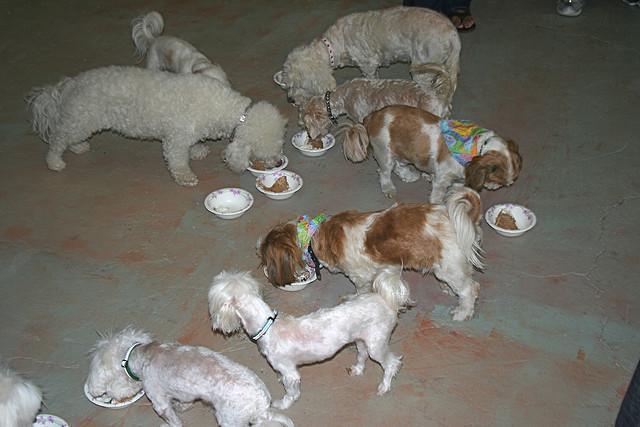How many bowls are empty?
Give a very brief answer. 1. How many dogs are visible?
Give a very brief answer. 8. 